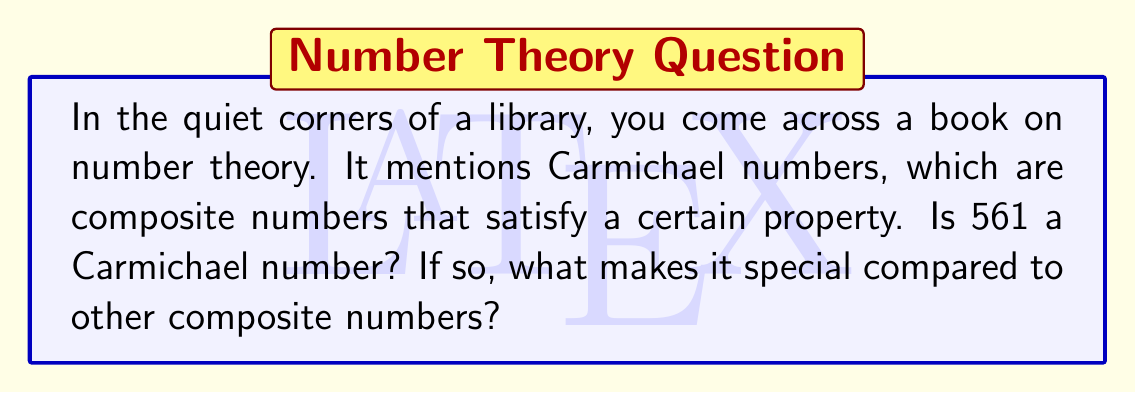Show me your answer to this math problem. Let's approach this step-by-step:

1) First, recall the definition of a Carmichael number:
   A composite number $n$ is a Carmichael number if for every integer $b$ coprime to $n$, 
   $b^{n-1} \equiv 1 \pmod{n}$.

2) We need to check if 561 is composite:
   $561 = 3 \times 11 \times 17$
   So, 561 is indeed composite.

3) Now, we need to verify if it satisfies the Carmichael property for all $b$ coprime to 561.
   
4) Instead of checking all such $b$, we can use Korselt's criterion:
   A composite number $n$ is a Carmichael number if and only if it is square-free and for every prime factor $p$ of $n$, $p-1$ divides $n-1$.

5) Let's check:
   - 561 is square-free (no repeated prime factors)
   - For $p = 3$: $3-1 = 2$ divides $561-1 = 560$
   - For $p = 11$: $11-1 = 10$ divides $561-1 = 560$
   - For $p = 17$: $17-1 = 16$ divides $561-1 = 560$

6) Since all conditions are satisfied, 561 is indeed a Carmichael number.

What makes Carmichael numbers special is that they pass a primality test (Fermat's little theorem) despite being composite. This property makes them "pseudoprimes" and can fool some primality testing algorithms.
Answer: Yes, 561 is a Carmichael number. 